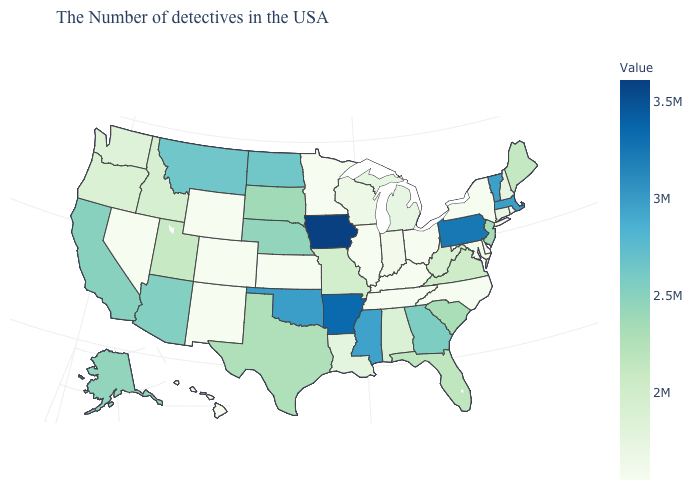Does Rhode Island have the lowest value in the Northeast?
Concise answer only. Yes. Among the states that border South Dakota , which have the highest value?
Concise answer only. Iowa. Which states hav the highest value in the West?
Write a very short answer. Montana. Among the states that border Idaho , does Oregon have the lowest value?
Concise answer only. No. Among the states that border Oregon , which have the highest value?
Quick response, please. California. Does Minnesota have a lower value than West Virginia?
Quick response, please. Yes. Does Virginia have the lowest value in the USA?
Write a very short answer. No. 